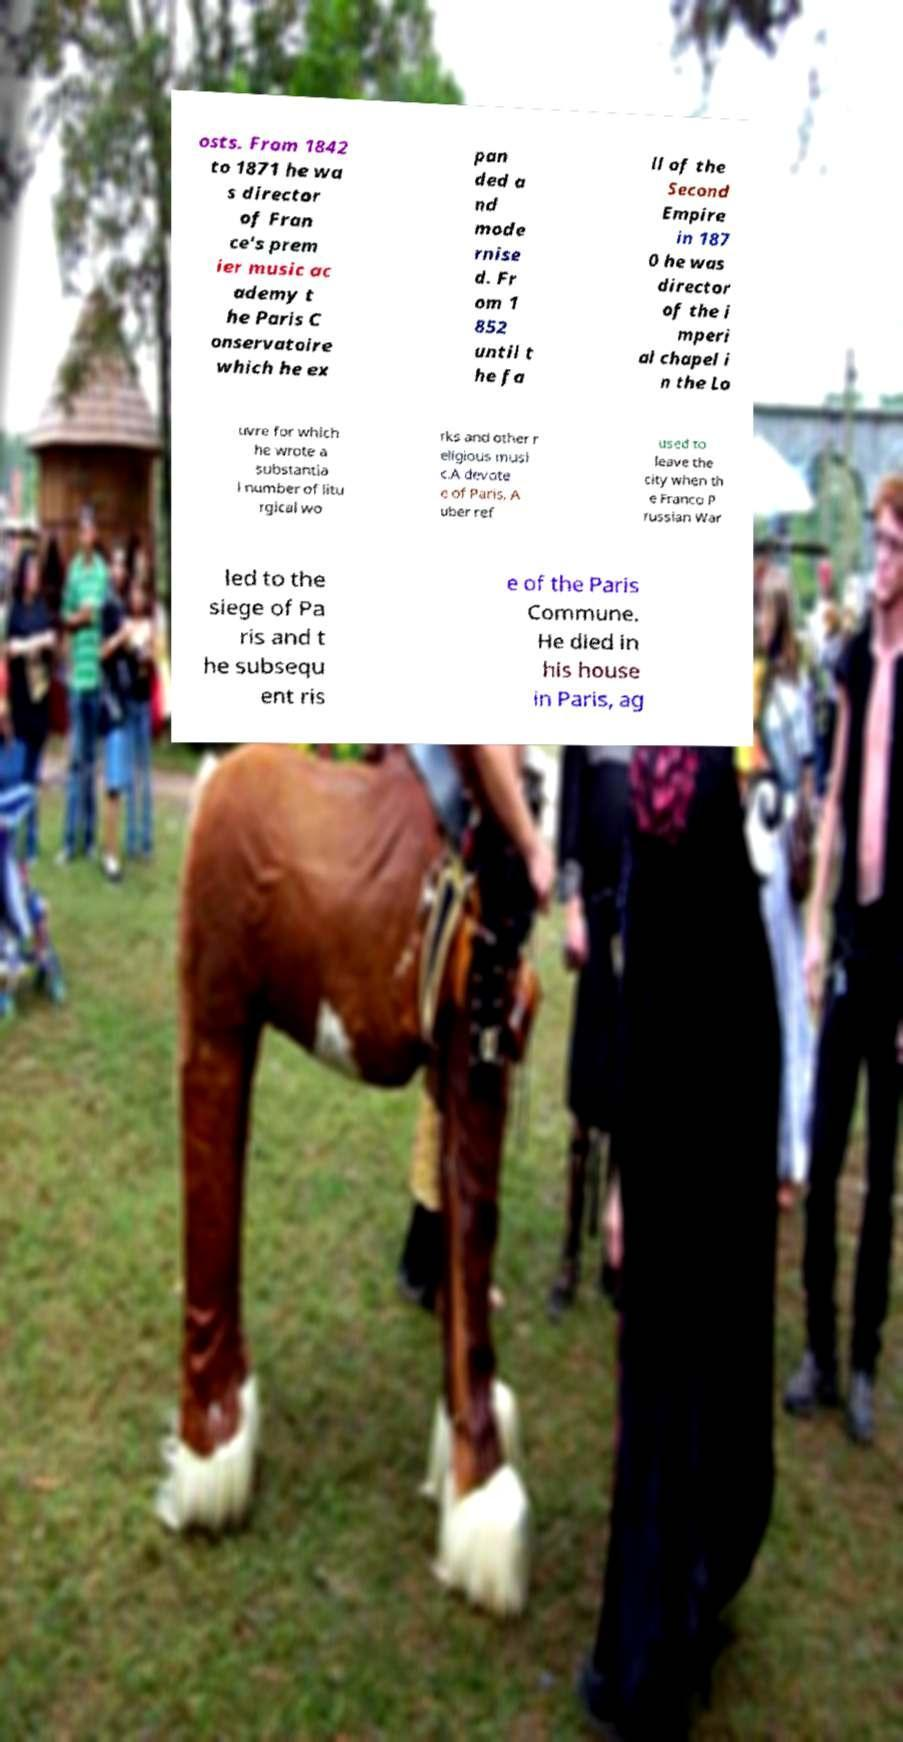Can you read and provide the text displayed in the image?This photo seems to have some interesting text. Can you extract and type it out for me? osts. From 1842 to 1871 he wa s director of Fran ce's prem ier music ac ademy t he Paris C onservatoire which he ex pan ded a nd mode rnise d. Fr om 1 852 until t he fa ll of the Second Empire in 187 0 he was director of the i mperi al chapel i n the Lo uvre for which he wrote a substantia l number of litu rgical wo rks and other r eligious musi c.A devote e of Paris, A uber ref used to leave the city when th e Franco P russian War led to the siege of Pa ris and t he subsequ ent ris e of the Paris Commune. He died in his house in Paris, ag 